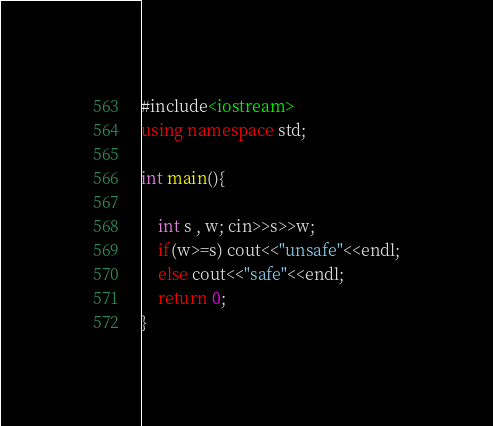Convert code to text. <code><loc_0><loc_0><loc_500><loc_500><_C++_>#include<iostream>
using namespace std;

int main(){

    int s , w; cin>>s>>w;
    if(w>=s) cout<<"unsafe"<<endl;
    else cout<<"safe"<<endl;
    return 0;
}</code> 